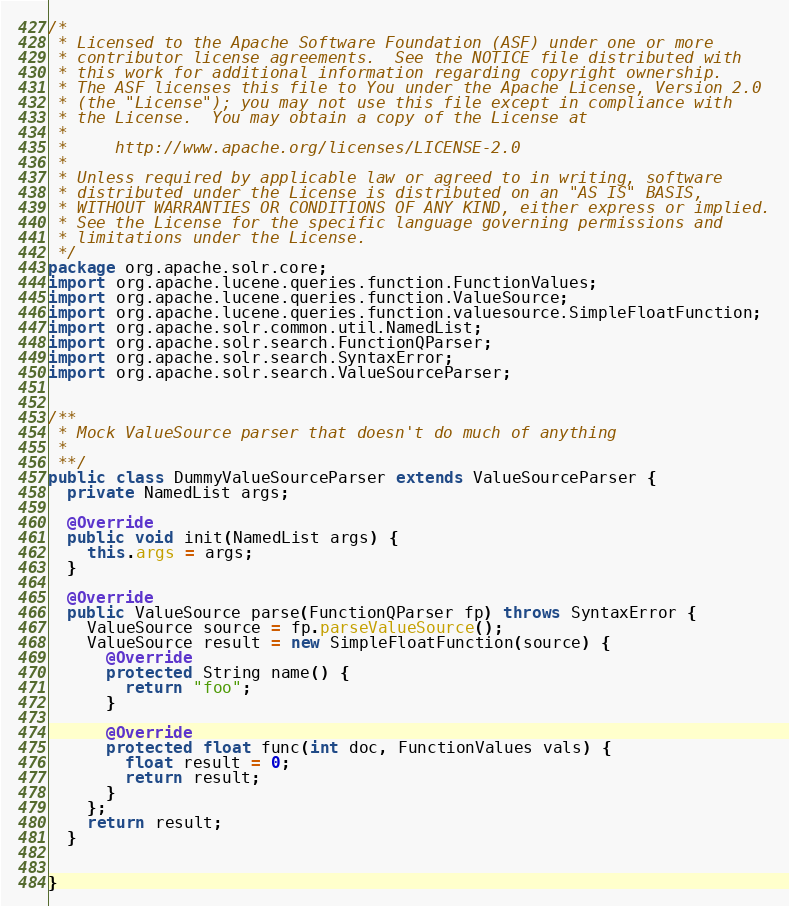<code> <loc_0><loc_0><loc_500><loc_500><_Java_>/*
 * Licensed to the Apache Software Foundation (ASF) under one or more
 * contributor license agreements.  See the NOTICE file distributed with
 * this work for additional information regarding copyright ownership.
 * The ASF licenses this file to You under the Apache License, Version 2.0
 * (the "License"); you may not use this file except in compliance with
 * the License.  You may obtain a copy of the License at
 *
 *     http://www.apache.org/licenses/LICENSE-2.0
 *
 * Unless required by applicable law or agreed to in writing, software
 * distributed under the License is distributed on an "AS IS" BASIS,
 * WITHOUT WARRANTIES OR CONDITIONS OF ANY KIND, either express or implied.
 * See the License for the specific language governing permissions and
 * limitations under the License.
 */
package org.apache.solr.core;
import org.apache.lucene.queries.function.FunctionValues;
import org.apache.lucene.queries.function.ValueSource;
import org.apache.lucene.queries.function.valuesource.SimpleFloatFunction;
import org.apache.solr.common.util.NamedList;
import org.apache.solr.search.FunctionQParser;
import org.apache.solr.search.SyntaxError;
import org.apache.solr.search.ValueSourceParser;


/**
 * Mock ValueSource parser that doesn't do much of anything
 *
 **/
public class DummyValueSourceParser extends ValueSourceParser {
  private NamedList args;

  @Override
  public void init(NamedList args) {
    this.args = args;
  }

  @Override
  public ValueSource parse(FunctionQParser fp) throws SyntaxError {
    ValueSource source = fp.parseValueSource();
    ValueSource result = new SimpleFloatFunction(source) {
      @Override
      protected String name() {
        return "foo";
      }

      @Override
      protected float func(int doc, FunctionValues vals) {
        float result = 0;
        return result;
      }
    };
    return result;
  }


}
</code> 